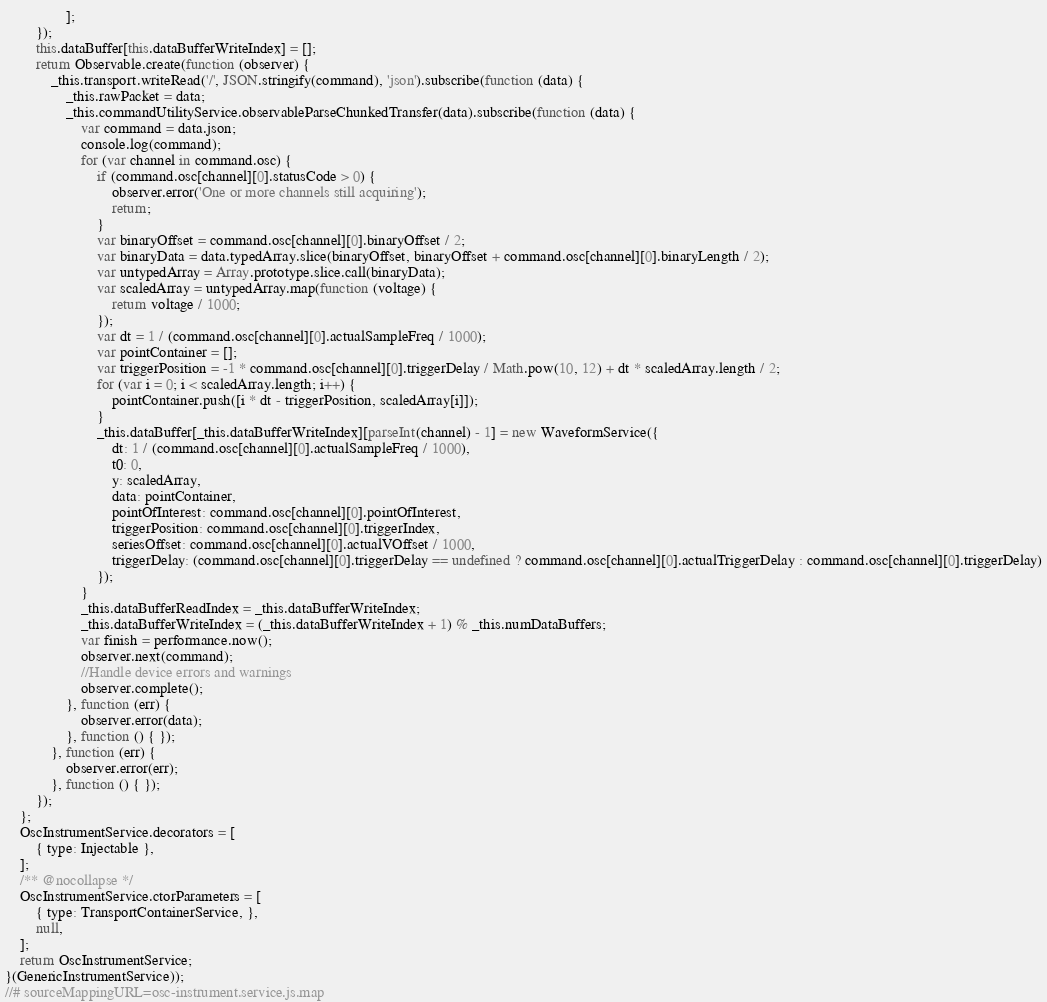<code> <loc_0><loc_0><loc_500><loc_500><_JavaScript_>                ];
        });
        this.dataBuffer[this.dataBufferWriteIndex] = [];
        return Observable.create(function (observer) {
            _this.transport.writeRead('/', JSON.stringify(command), 'json').subscribe(function (data) {
                _this.rawPacket = data;
                _this.commandUtilityService.observableParseChunkedTransfer(data).subscribe(function (data) {
                    var command = data.json;
                    console.log(command);
                    for (var channel in command.osc) {
                        if (command.osc[channel][0].statusCode > 0) {
                            observer.error('One or more channels still acquiring');
                            return;
                        }
                        var binaryOffset = command.osc[channel][0].binaryOffset / 2;
                        var binaryData = data.typedArray.slice(binaryOffset, binaryOffset + command.osc[channel][0].binaryLength / 2);
                        var untypedArray = Array.prototype.slice.call(binaryData);
                        var scaledArray = untypedArray.map(function (voltage) {
                            return voltage / 1000;
                        });
                        var dt = 1 / (command.osc[channel][0].actualSampleFreq / 1000);
                        var pointContainer = [];
                        var triggerPosition = -1 * command.osc[channel][0].triggerDelay / Math.pow(10, 12) + dt * scaledArray.length / 2;
                        for (var i = 0; i < scaledArray.length; i++) {
                            pointContainer.push([i * dt - triggerPosition, scaledArray[i]]);
                        }
                        _this.dataBuffer[_this.dataBufferWriteIndex][parseInt(channel) - 1] = new WaveformService({
                            dt: 1 / (command.osc[channel][0].actualSampleFreq / 1000),
                            t0: 0,
                            y: scaledArray,
                            data: pointContainer,
                            pointOfInterest: command.osc[channel][0].pointOfInterest,
                            triggerPosition: command.osc[channel][0].triggerIndex,
                            seriesOffset: command.osc[channel][0].actualVOffset / 1000,
                            triggerDelay: (command.osc[channel][0].triggerDelay == undefined ? command.osc[channel][0].actualTriggerDelay : command.osc[channel][0].triggerDelay)
                        });
                    }
                    _this.dataBufferReadIndex = _this.dataBufferWriteIndex;
                    _this.dataBufferWriteIndex = (_this.dataBufferWriteIndex + 1) % _this.numDataBuffers;
                    var finish = performance.now();
                    observer.next(command);
                    //Handle device errors and warnings
                    observer.complete();
                }, function (err) {
                    observer.error(data);
                }, function () { });
            }, function (err) {
                observer.error(err);
            }, function () { });
        });
    };
    OscInstrumentService.decorators = [
        { type: Injectable },
    ];
    /** @nocollapse */
    OscInstrumentService.ctorParameters = [
        { type: TransportContainerService, },
        null,
    ];
    return OscInstrumentService;
}(GenericInstrumentService));
//# sourceMappingURL=osc-instrument.service.js.map</code> 